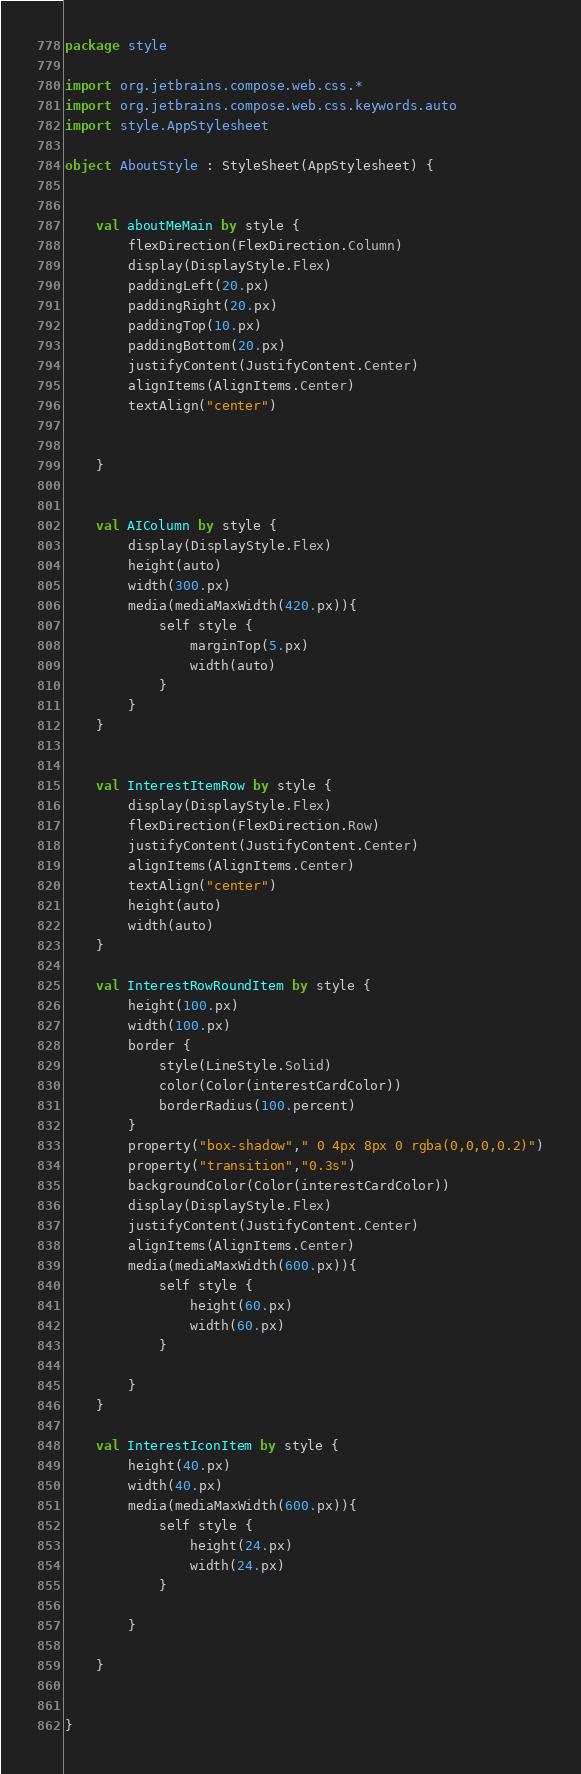Convert code to text. <code><loc_0><loc_0><loc_500><loc_500><_Kotlin_>package style

import org.jetbrains.compose.web.css.*
import org.jetbrains.compose.web.css.keywords.auto
import style.AppStylesheet

object AboutStyle : StyleSheet(AppStylesheet) {


    val aboutMeMain by style {
        flexDirection(FlexDirection.Column)
        display(DisplayStyle.Flex)
        paddingLeft(20.px)
        paddingRight(20.px)
        paddingTop(10.px)
        paddingBottom(20.px)
        justifyContent(JustifyContent.Center)
        alignItems(AlignItems.Center)
        textAlign("center")


    }


    val AIColumn by style {
        display(DisplayStyle.Flex)
        height(auto)
        width(300.px)
        media(mediaMaxWidth(420.px)){
            self style {
                marginTop(5.px)
                width(auto)
            }
        }
    }


    val InterestItemRow by style {
        display(DisplayStyle.Flex)
        flexDirection(FlexDirection.Row)
        justifyContent(JustifyContent.Center)
        alignItems(AlignItems.Center)
        textAlign("center")
        height(auto)
        width(auto)
    }

    val InterestRowRoundItem by style {
        height(100.px)
        width(100.px)
        border {
            style(LineStyle.Solid)
            color(Color(interestCardColor))
            borderRadius(100.percent)
        }
        property("box-shadow"," 0 4px 8px 0 rgba(0,0,0,0.2)")
        property("transition","0.3s")
        backgroundColor(Color(interestCardColor))
        display(DisplayStyle.Flex)
        justifyContent(JustifyContent.Center)
        alignItems(AlignItems.Center)
        media(mediaMaxWidth(600.px)){
            self style {
                height(60.px)
                width(60.px)
            }

        }
    }

    val InterestIconItem by style {
        height(40.px)
        width(40.px)
        media(mediaMaxWidth(600.px)){
            self style {
                height(24.px)
                width(24.px)
            }

        }

    }


}
</code> 